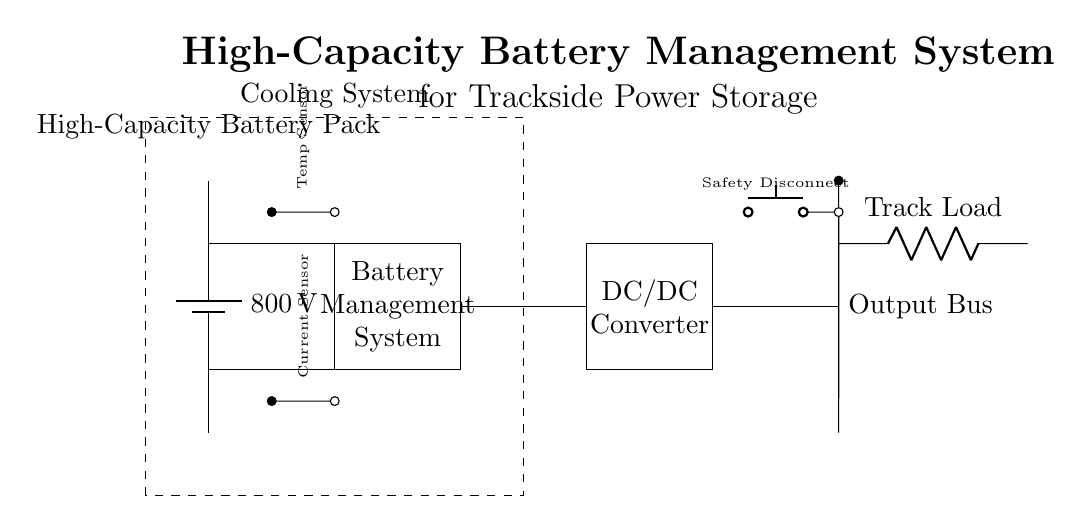What is the voltage of the battery pack? The voltage of the battery pack is indicated on the component label in the circuit diagram, which states 800 volts.
Answer: 800 volts What component connects the battery to the Battery Management System? The connection is shown by solid lines in the diagram, where the top and bottom terminals of the battery connect directly to the corresponding terminals of the Battery Management System.
Answer: Connecting wires What is the purpose of the DC/DC Converter in the circuit? The DC/DC Converter is used to convert the voltage output from the Battery Management System to the appropriate voltage level required by the track load. This is necessary to ensure that the load operates efficiently without overloading.
Answer: Voltage conversion How many sensors are present in the circuit? Two sensors are displayed in the circuit diagram, one labeled as a temperature sensor and the other as a current sensor. They are represented by small circles with connecting lines to the Battery Management System.
Answer: Two sensors What safety feature is included in this circuit? The circuit includes a safety disconnect feature, indicated by a push button in the diagram, which can be used to disconnect the entire output from the battery system safely.
Answer: Safety disconnect What is the function of the cooling system in the circuit? The cooling system is necessary to maintain the temperature of the battery pack and other components within safe limits during operation. This ensures efficient performance and prevents damage due to overheating.
Answer: Temperature regulation 